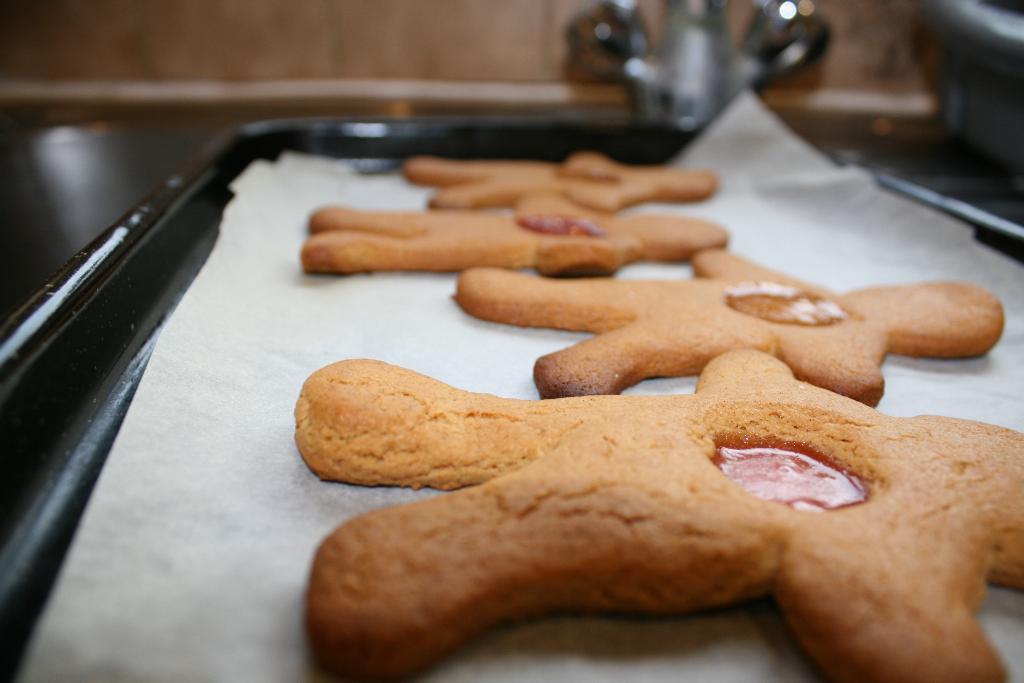Could you give a brief overview of what you see in this image? In this image I can see the food in the black color tray. In the background I can see something is attached to the brown color surface. 